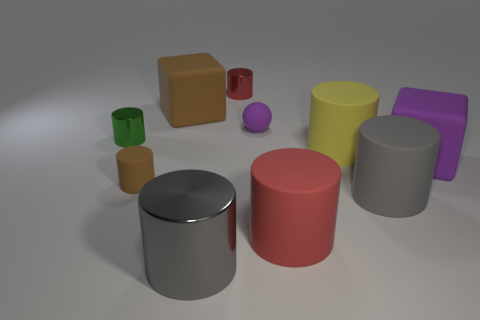What number of rubber things are either large brown objects or purple cylinders?
Make the answer very short. 1. Is the number of small green rubber objects less than the number of big yellow matte objects?
Keep it short and to the point. Yes. There is a brown matte cylinder; is it the same size as the gray thing that is to the right of the gray metallic thing?
Provide a succinct answer. No. Is there anything else that is the same shape as the green shiny thing?
Your response must be concise. Yes. How big is the green cylinder?
Offer a very short reply. Small. Are there fewer small brown matte objects to the right of the brown matte cylinder than red rubber cylinders?
Offer a terse response. Yes. Do the green metal object and the gray rubber cylinder have the same size?
Your answer should be very brief. No. The tiny cylinder that is made of the same material as the tiny purple object is what color?
Ensure brevity in your answer.  Brown. Is the number of small purple things in front of the large red matte cylinder less than the number of small purple things that are on the right side of the large yellow cylinder?
Provide a short and direct response. No. How many big cylinders are the same color as the rubber sphere?
Offer a terse response. 0. 